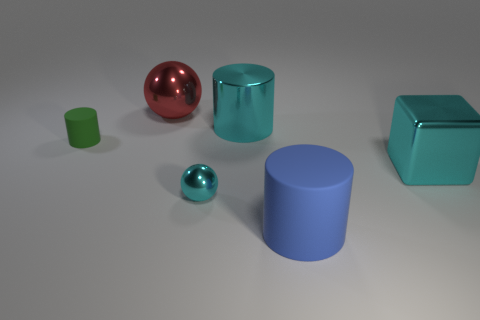There is a large object that is the same color as the cube; what shape is it?
Offer a terse response. Cylinder. What number of red objects are either big shiny objects or large metal cubes?
Offer a very short reply. 1. There is a large blue object that is the same shape as the green matte object; what is it made of?
Your answer should be compact. Rubber. Are there the same number of red things that are in front of the tiny green rubber thing and tiny yellow metal spheres?
Keep it short and to the point. Yes. How big is the object that is behind the blue matte object and in front of the big metal cube?
Keep it short and to the point. Small. Are there any other things of the same color as the small metal sphere?
Ensure brevity in your answer.  Yes. What is the size of the matte object that is on the right side of the sphere behind the small shiny object?
Keep it short and to the point. Large. The large metal object that is both right of the tiny cyan object and on the left side of the large metal block is what color?
Provide a succinct answer. Cyan. What number of other objects are the same size as the blue thing?
Your response must be concise. 3. Does the green rubber thing have the same size as the cyan shiny thing that is in front of the block?
Offer a terse response. Yes. 